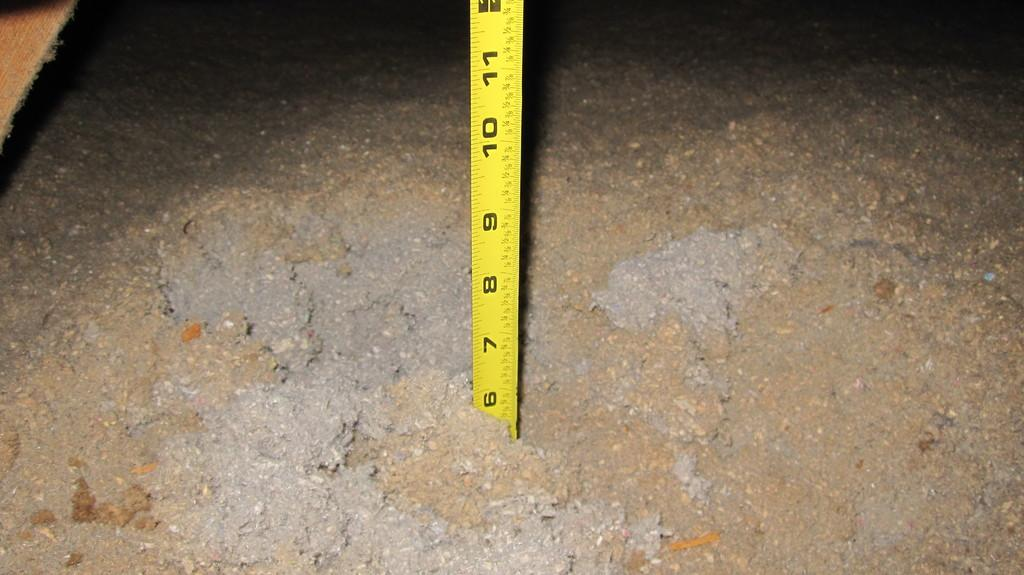<image>
Offer a succinct explanation of the picture presented. A tape measure is stuck in a pile of insulation up to the 6 inch mark. 